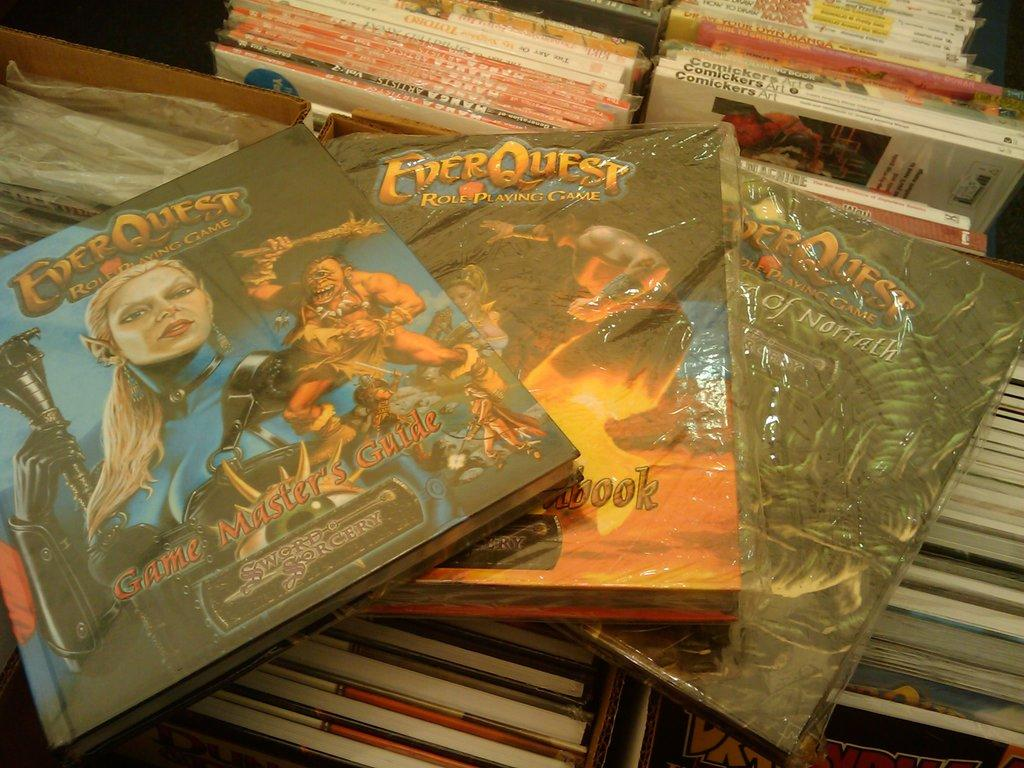What is the primary subject of the image? The primary subject of the image is many books. Can you describe the books in the image? The image shows a collection of books, but no specific details about the books are provided. Are there any other objects or elements in the image besides the books? The provided facts do not mention any other objects or elements in the image. How many deer can be seen grazing near the books in the image? There are no deer present in the image; it only features books. 